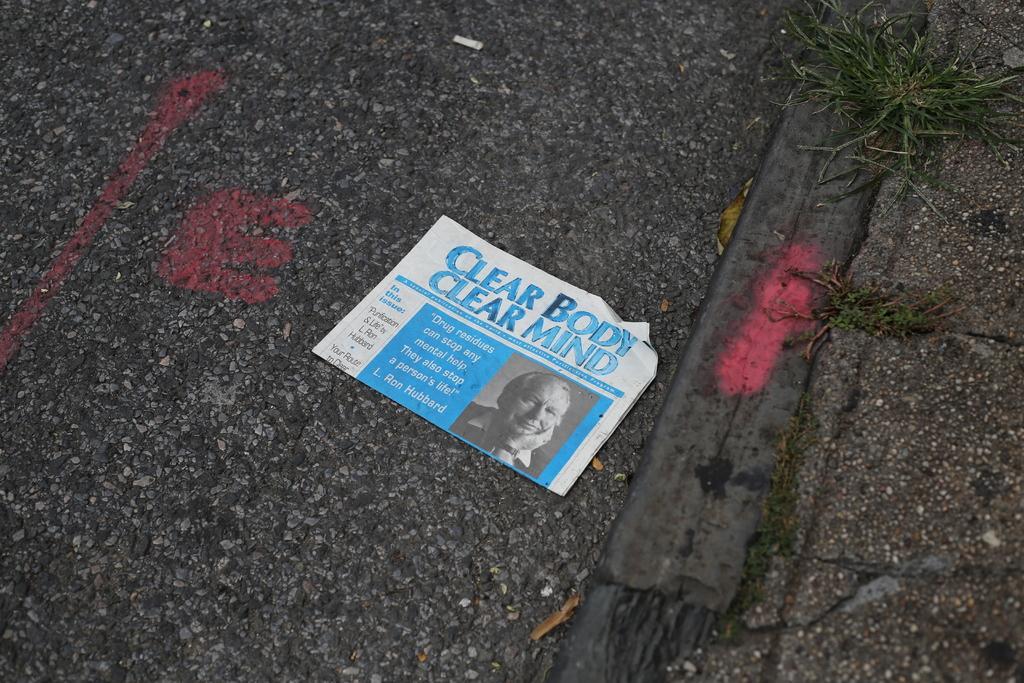In one or two sentences, can you explain what this image depicts? In a given image I can see a paper with some text and grass. 